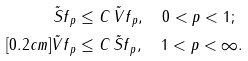<formula> <loc_0><loc_0><loc_500><loc_500>\| \tilde { S } f \| _ { p } & \leq C \, \| \tilde { V } f \| _ { p } , \quad 0 < p < 1 ; \\ [ 0 . 2 c m ] \| \tilde { V } f \| _ { p } & \leq C \, \| \tilde { S } f \| _ { p } , \quad 1 < p < \infty .</formula> 